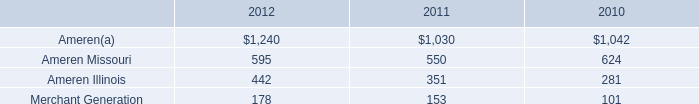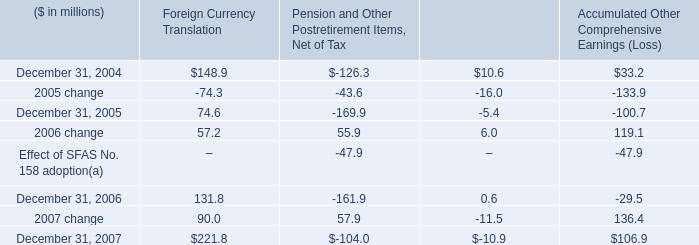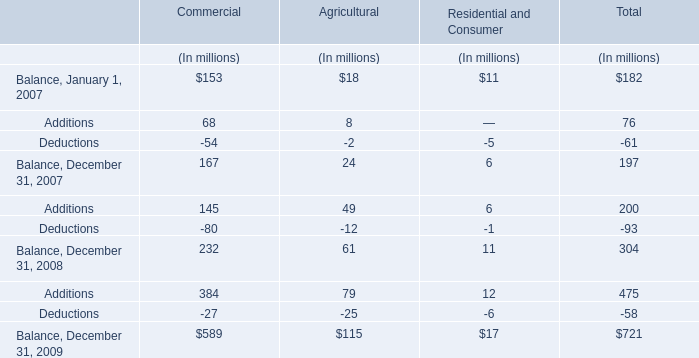what was the net tax expense for the 3 years ended 2005 related to the change in financial derivatives ( in millions? ) 
Computations: ((5.7 - 3.2) - 10.7)
Answer: -8.2. 